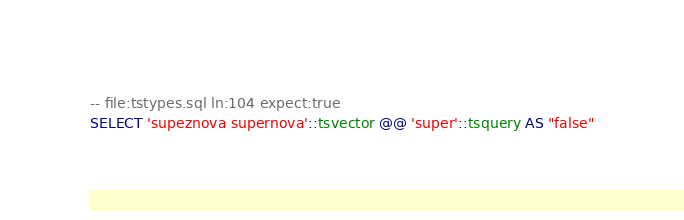<code> <loc_0><loc_0><loc_500><loc_500><_SQL_>-- file:tstypes.sql ln:104 expect:true
SELECT 'supeznova supernova'::tsvector @@ 'super'::tsquery AS "false"
</code> 